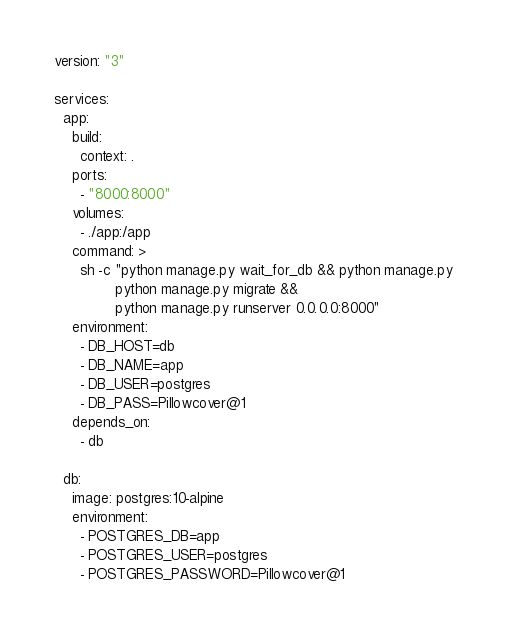<code> <loc_0><loc_0><loc_500><loc_500><_YAML_>version: "3"

services:
  app:
    build:
      context: .
    ports:
      - "8000:8000"
    volumes:
      - ./app:/app
    command: >
      sh -c "python manage.py wait_for_db && python manage.py
              python manage.py migrate &&
              python manage.py runserver 0.0.0.0:8000"
    environment:
      - DB_HOST=db
      - DB_NAME=app
      - DB_USER=postgres
      - DB_PASS=Pillowcover@1
    depends_on:
      - db

  db:
    image: postgres:10-alpine
    environment:
      - POSTGRES_DB=app
      - POSTGRES_USER=postgres
      - POSTGRES_PASSWORD=Pillowcover@1
</code> 